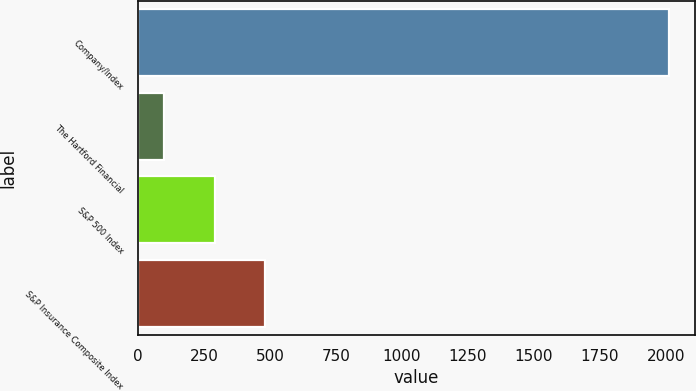<chart> <loc_0><loc_0><loc_500><loc_500><bar_chart><fcel>Company/Index<fcel>The Hartford Financial<fcel>S&P 500 Index<fcel>S&P Insurance Composite Index<nl><fcel>2011<fcel>100<fcel>291.1<fcel>482.2<nl></chart> 